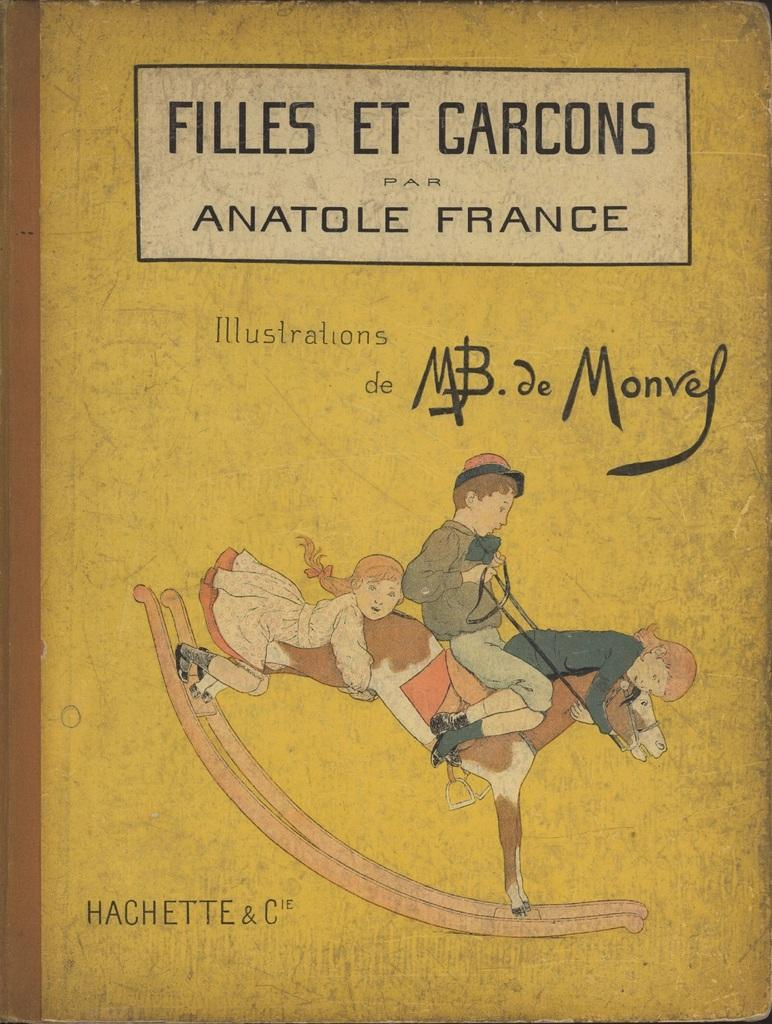<image>
Describe the image concisely. a book that has the word filles in it 